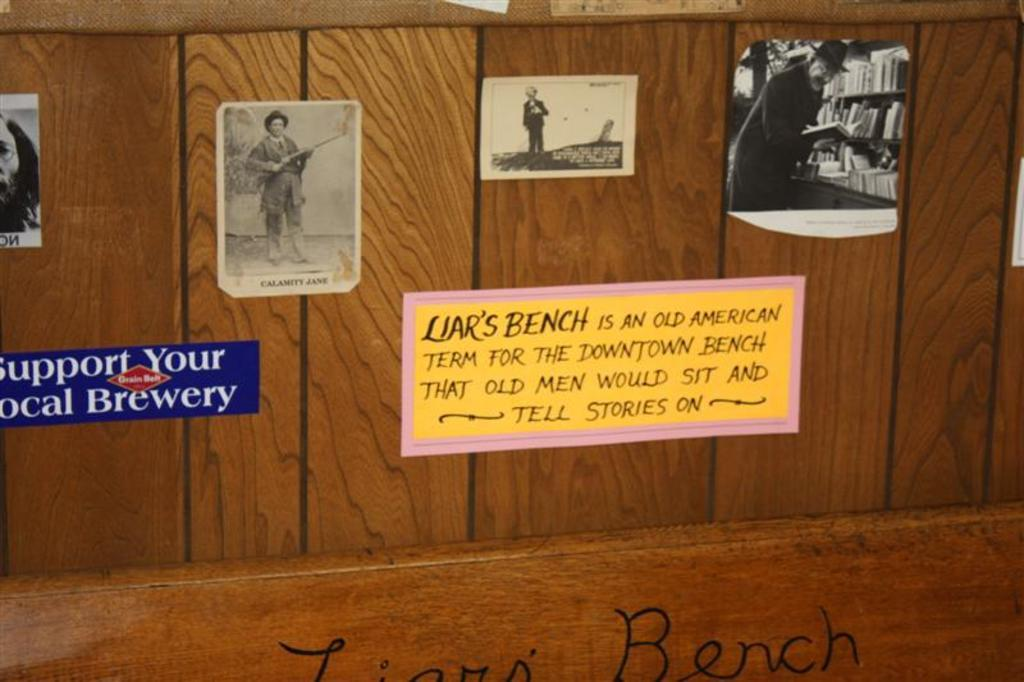<image>
Describe the image concisely. The blue and red sticker is for Grain Belt Beer 